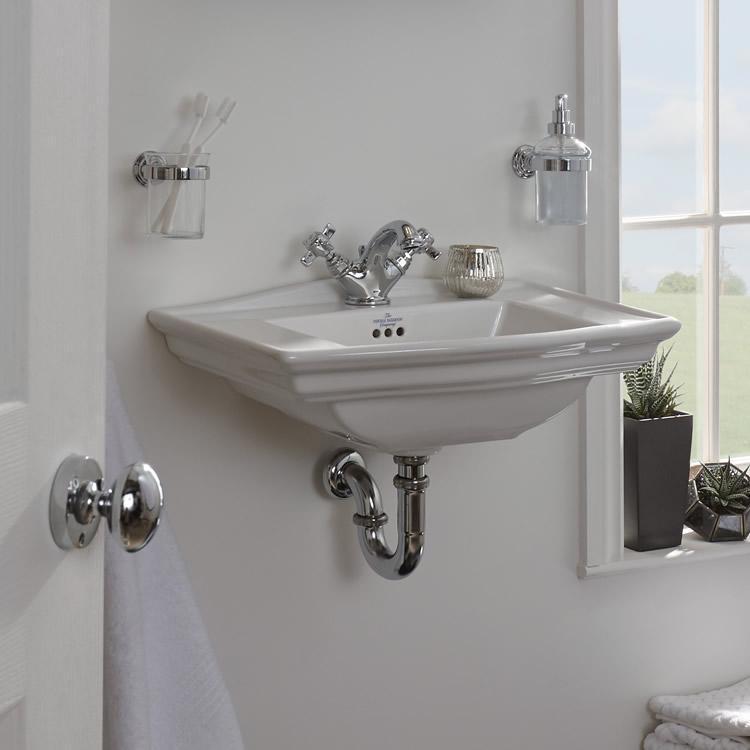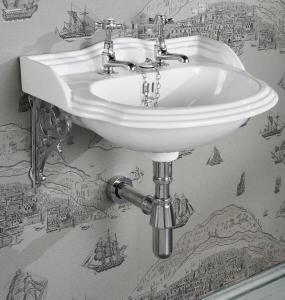The first image is the image on the left, the second image is the image on the right. Assess this claim about the two images: "The combined images include two wall-mounted sinks with metal pipes exposed underneath them, and at least one sink has faucets integrated with the spout.". Correct or not? Answer yes or no. Yes. The first image is the image on the left, the second image is the image on the right. For the images displayed, is the sentence "Exactly two bathroom sinks are shown, one with hot and cold water faucets, while the other has a single unright faucet." factually correct? Answer yes or no. No. 